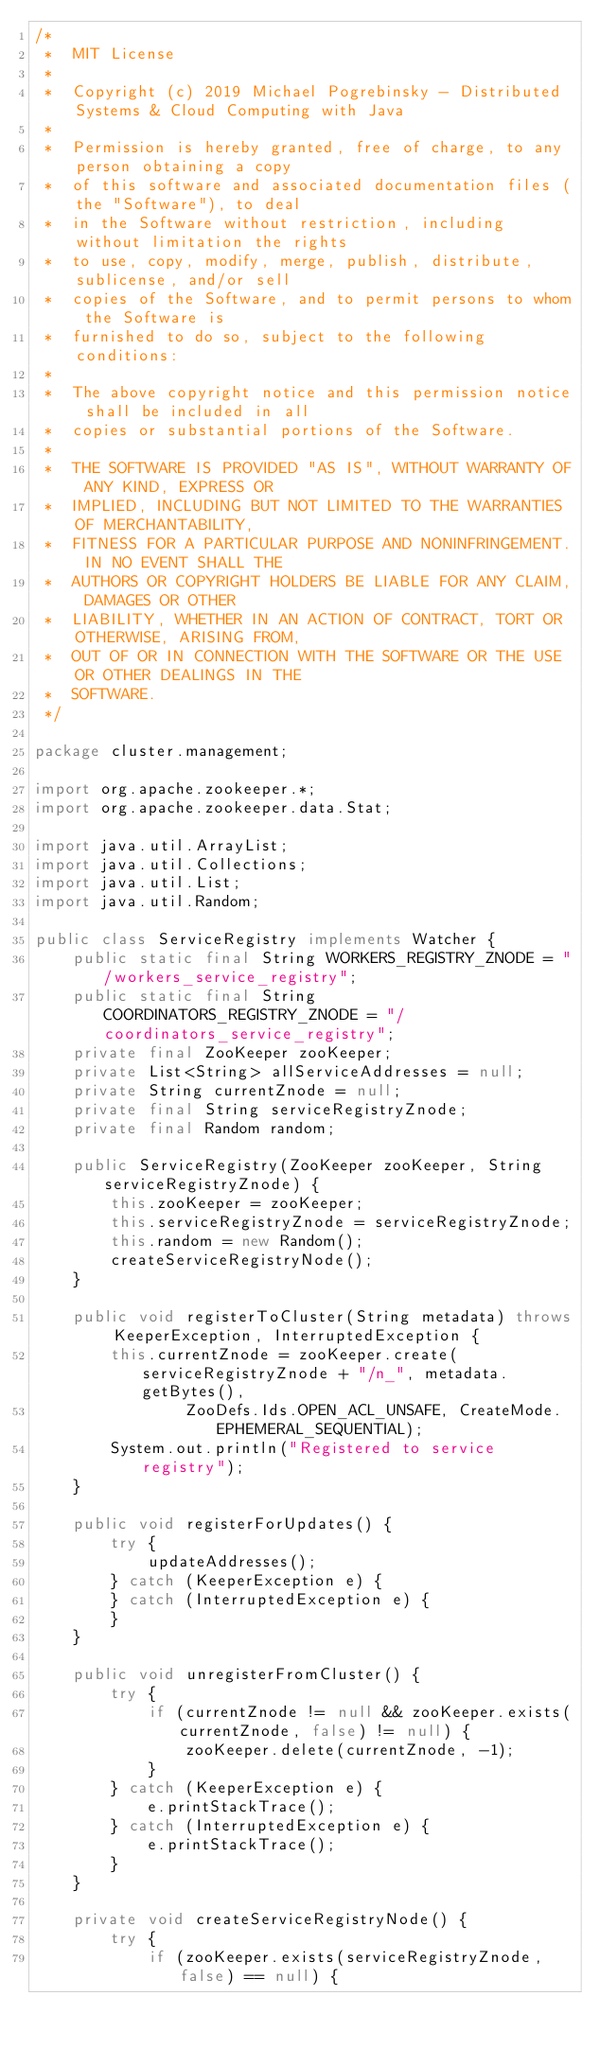<code> <loc_0><loc_0><loc_500><loc_500><_Java_>/*
 *  MIT License
 *
 *  Copyright (c) 2019 Michael Pogrebinsky - Distributed Systems & Cloud Computing with Java
 *
 *  Permission is hereby granted, free of charge, to any person obtaining a copy
 *  of this software and associated documentation files (the "Software"), to deal
 *  in the Software without restriction, including without limitation the rights
 *  to use, copy, modify, merge, publish, distribute, sublicense, and/or sell
 *  copies of the Software, and to permit persons to whom the Software is
 *  furnished to do so, subject to the following conditions:
 *
 *  The above copyright notice and this permission notice shall be included in all
 *  copies or substantial portions of the Software.
 *
 *  THE SOFTWARE IS PROVIDED "AS IS", WITHOUT WARRANTY OF ANY KIND, EXPRESS OR
 *  IMPLIED, INCLUDING BUT NOT LIMITED TO THE WARRANTIES OF MERCHANTABILITY,
 *  FITNESS FOR A PARTICULAR PURPOSE AND NONINFRINGEMENT. IN NO EVENT SHALL THE
 *  AUTHORS OR COPYRIGHT HOLDERS BE LIABLE FOR ANY CLAIM, DAMAGES OR OTHER
 *  LIABILITY, WHETHER IN AN ACTION OF CONTRACT, TORT OR OTHERWISE, ARISING FROM,
 *  OUT OF OR IN CONNECTION WITH THE SOFTWARE OR THE USE OR OTHER DEALINGS IN THE
 *  SOFTWARE.
 */

package cluster.management;

import org.apache.zookeeper.*;
import org.apache.zookeeper.data.Stat;

import java.util.ArrayList;
import java.util.Collections;
import java.util.List;
import java.util.Random;

public class ServiceRegistry implements Watcher {
    public static final String WORKERS_REGISTRY_ZNODE = "/workers_service_registry";
    public static final String COORDINATORS_REGISTRY_ZNODE = "/coordinators_service_registry";
    private final ZooKeeper zooKeeper;
    private List<String> allServiceAddresses = null;
    private String currentZnode = null;
    private final String serviceRegistryZnode;
    private final Random random;

    public ServiceRegistry(ZooKeeper zooKeeper, String serviceRegistryZnode) {
        this.zooKeeper = zooKeeper;
        this.serviceRegistryZnode = serviceRegistryZnode;
        this.random = new Random();
        createServiceRegistryNode();
    }

    public void registerToCluster(String metadata) throws KeeperException, InterruptedException {
        this.currentZnode = zooKeeper.create(serviceRegistryZnode + "/n_", metadata.getBytes(),
                ZooDefs.Ids.OPEN_ACL_UNSAFE, CreateMode.EPHEMERAL_SEQUENTIAL);
        System.out.println("Registered to service registry");
    }

    public void registerForUpdates() {
        try {
            updateAddresses();
        } catch (KeeperException e) {
        } catch (InterruptedException e) {
        }
    }

    public void unregisterFromCluster() {
        try {
            if (currentZnode != null && zooKeeper.exists(currentZnode, false) != null) {
                zooKeeper.delete(currentZnode, -1);
            }
        } catch (KeeperException e) {
            e.printStackTrace();
        } catch (InterruptedException e) {
            e.printStackTrace();
        }
    }

    private void createServiceRegistryNode() {
        try {
            if (zooKeeper.exists(serviceRegistryZnode, false) == null) {</code> 